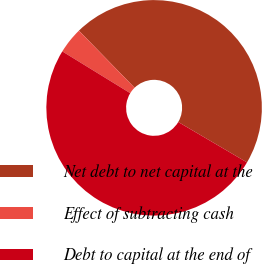<chart> <loc_0><loc_0><loc_500><loc_500><pie_chart><fcel>Net debt to net capital at the<fcel>Effect of subtracting cash<fcel>Debt to capital at the end of<nl><fcel>45.75%<fcel>3.93%<fcel>50.32%<nl></chart> 